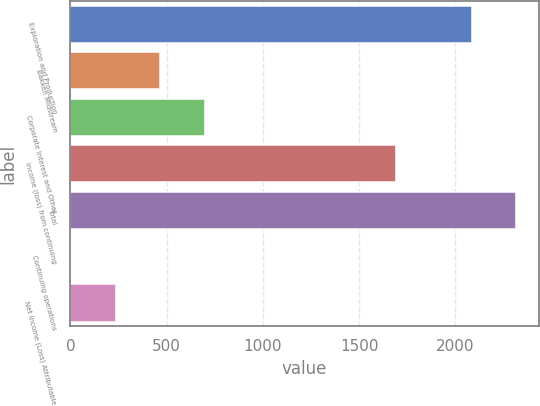Convert chart to OTSL. <chart><loc_0><loc_0><loc_500><loc_500><bar_chart><fcel>Exploration and Production<fcel>Bakken Midstream<fcel>Corporate Interest and Other<fcel>Income (loss) from continuing<fcel>Total<fcel>Continuing operations<fcel>Net Income (Loss) Attributable<nl><fcel>2086<fcel>467.8<fcel>698.95<fcel>1692<fcel>2317.15<fcel>5.5<fcel>236.65<nl></chart> 